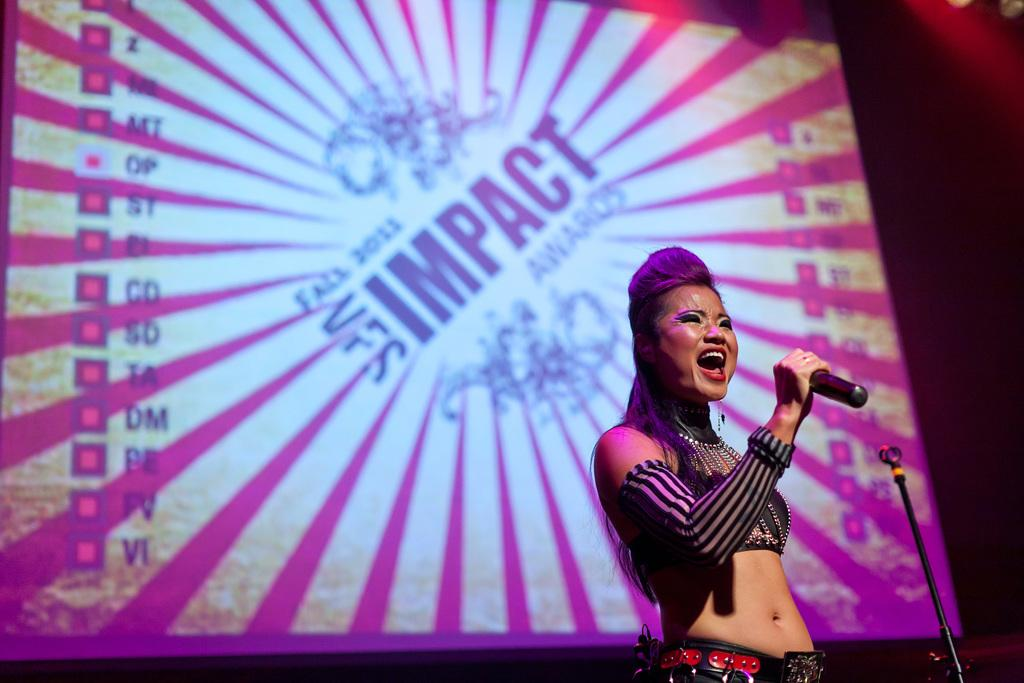What is the person in the image doing? The person is standing and holding a mic. What might the person be doing with the mic? The person might be using the mic for speaking or singing. What can be seen in the background of the image? There is a screen in the background of the image. What type of linen is draped over the side of the screen in the image? There is no linen draped over the side of the screen in the image. What time is displayed on the clock in the image? There is no clock present in the image. 